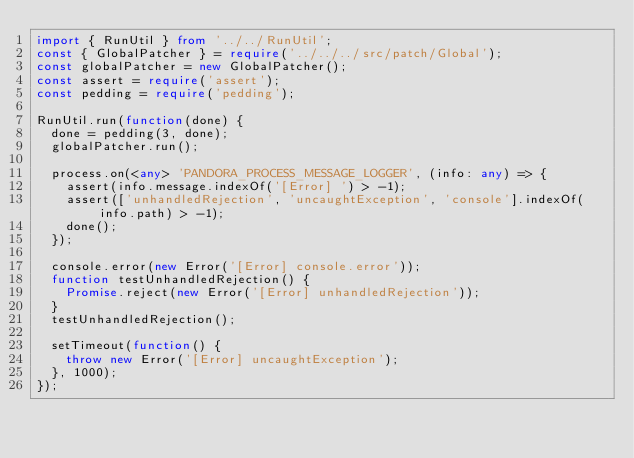Convert code to text. <code><loc_0><loc_0><loc_500><loc_500><_TypeScript_>import { RunUtil } from '../../RunUtil';
const { GlobalPatcher } = require('../../../src/patch/Global');
const globalPatcher = new GlobalPatcher();
const assert = require('assert');
const pedding = require('pedding');

RunUtil.run(function(done) {
  done = pedding(3, done);
  globalPatcher.run();

  process.on(<any> 'PANDORA_PROCESS_MESSAGE_LOGGER', (info: any) => {
    assert(info.message.indexOf('[Error] ') > -1);
    assert(['unhandledRejection', 'uncaughtException', 'console'].indexOf(info.path) > -1);
    done();
  });

  console.error(new Error('[Error] console.error'));
  function testUnhandledRejection() {
    Promise.reject(new Error('[Error] unhandledRejection'));
  }
  testUnhandledRejection();

  setTimeout(function() {
    throw new Error('[Error] uncaughtException');
  }, 1000);
});
</code> 